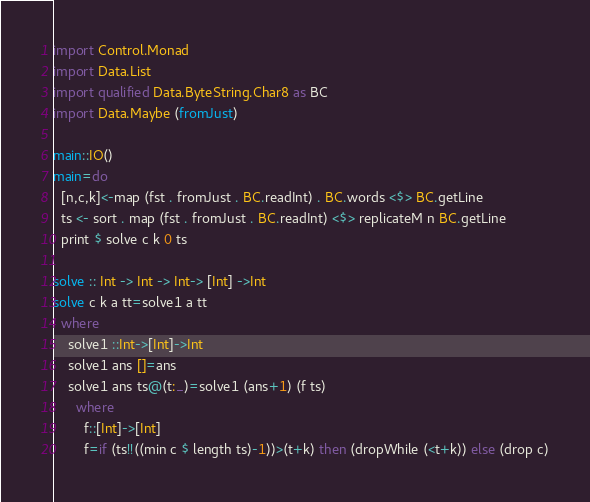Convert code to text. <code><loc_0><loc_0><loc_500><loc_500><_Haskell_>
import Control.Monad
import Data.List
import qualified Data.ByteString.Char8 as BC
import Data.Maybe (fromJust)

main::IO()
main=do
  [n,c,k]<-map (fst . fromJust . BC.readInt) . BC.words <$> BC.getLine
  ts <- sort . map (fst . fromJust . BC.readInt) <$> replicateM n BC.getLine
  print $ solve c k 0 ts

solve :: Int -> Int -> Int-> [Int] ->Int
solve c k a tt=solve1 a tt
  where
    solve1 ::Int->[Int]->Int
    solve1 ans []=ans
    solve1 ans ts@(t:_)=solve1 (ans+1) (f ts)
      where
        f::[Int]->[Int]
        f=if (ts!!((min c $ length ts)-1))>(t+k) then (dropWhile (<t+k)) else (drop c)
</code> 